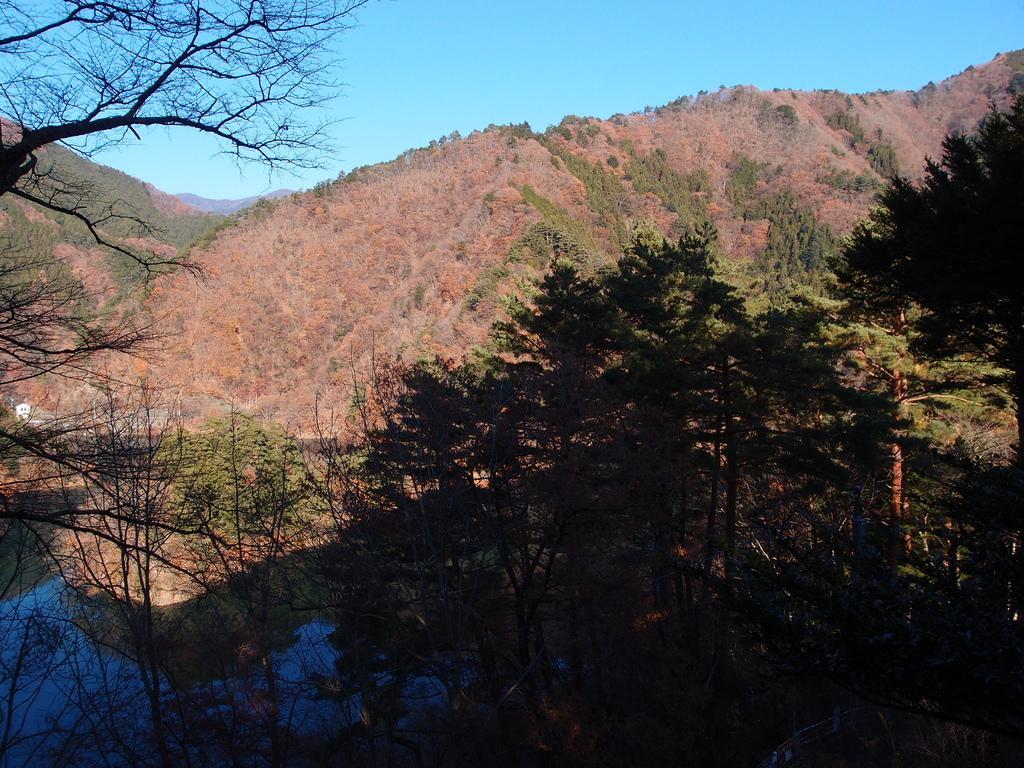Can you describe this image briefly? In the image there is a mountain and in front of the mountain there are a lot trees and some of them are dried trees. On the left side there is a small pond. 